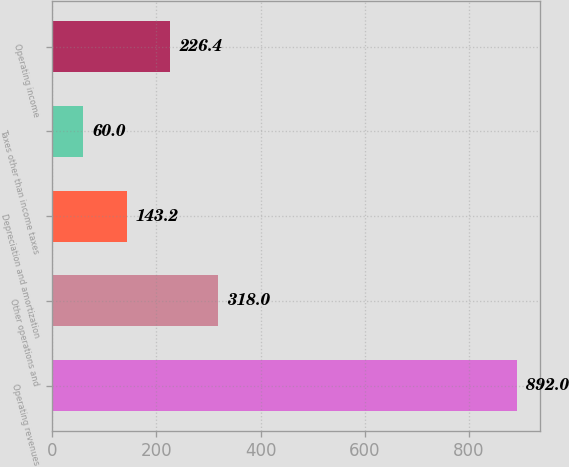<chart> <loc_0><loc_0><loc_500><loc_500><bar_chart><fcel>Operating revenues<fcel>Other operations and<fcel>Depreciation and amortization<fcel>Taxes other than income taxes<fcel>Operating income<nl><fcel>892<fcel>318<fcel>143.2<fcel>60<fcel>226.4<nl></chart> 